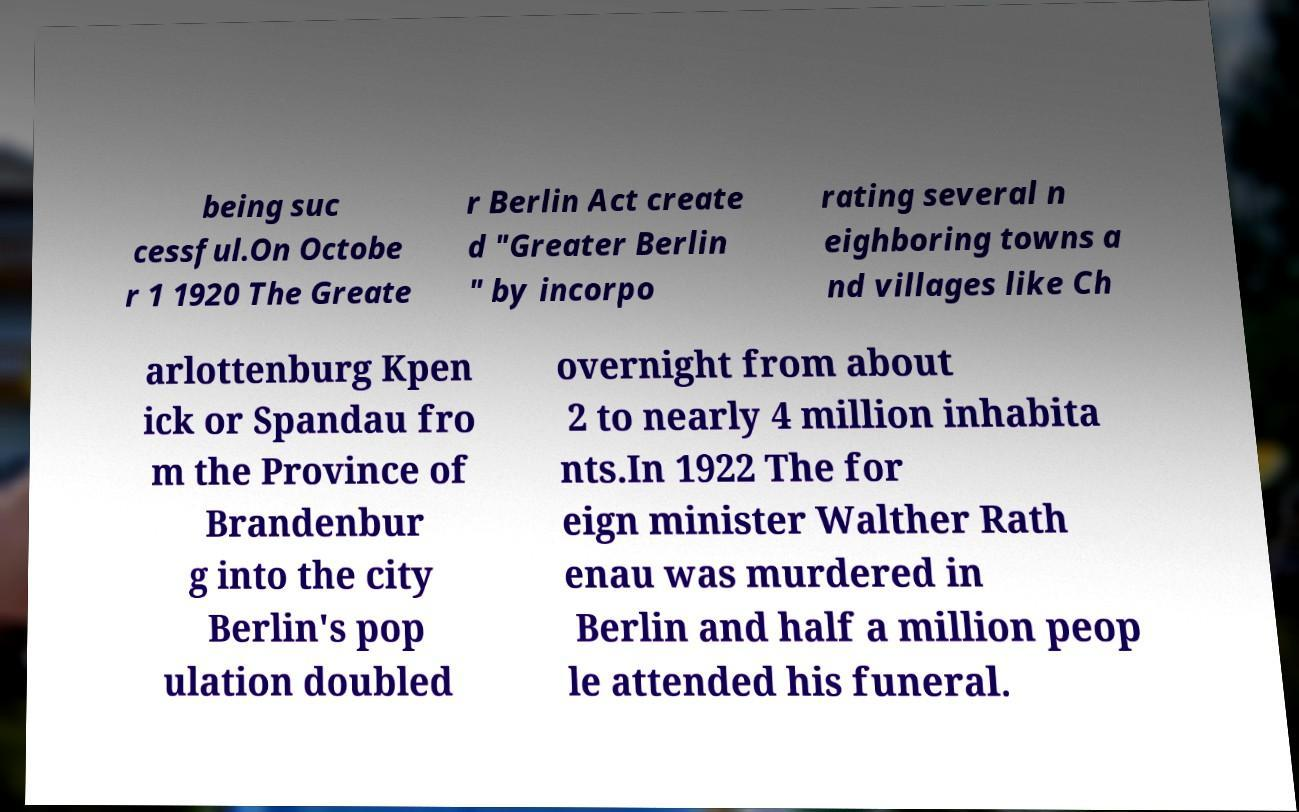Could you extract and type out the text from this image? being suc cessful.On Octobe r 1 1920 The Greate r Berlin Act create d "Greater Berlin " by incorpo rating several n eighboring towns a nd villages like Ch arlottenburg Kpen ick or Spandau fro m the Province of Brandenbur g into the city Berlin's pop ulation doubled overnight from about 2 to nearly 4 million inhabita nts.In 1922 The for eign minister Walther Rath enau was murdered in Berlin and half a million peop le attended his funeral. 